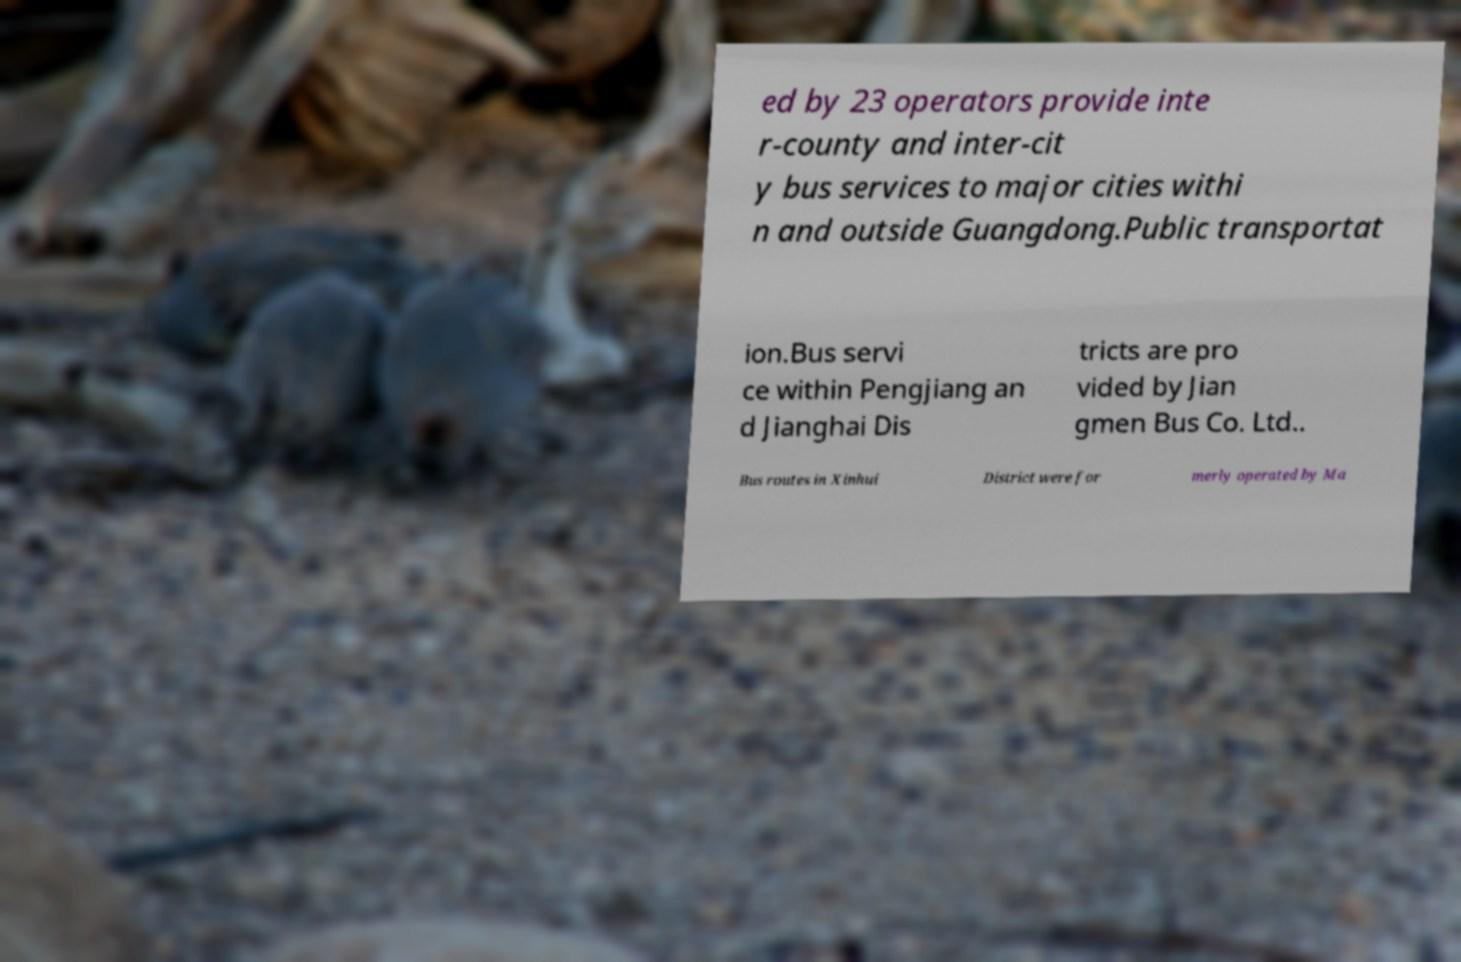Could you extract and type out the text from this image? ed by 23 operators provide inte r-county and inter-cit y bus services to major cities withi n and outside Guangdong.Public transportat ion.Bus servi ce within Pengjiang an d Jianghai Dis tricts are pro vided by Jian gmen Bus Co. Ltd.. Bus routes in Xinhui District were for merly operated by Ma 